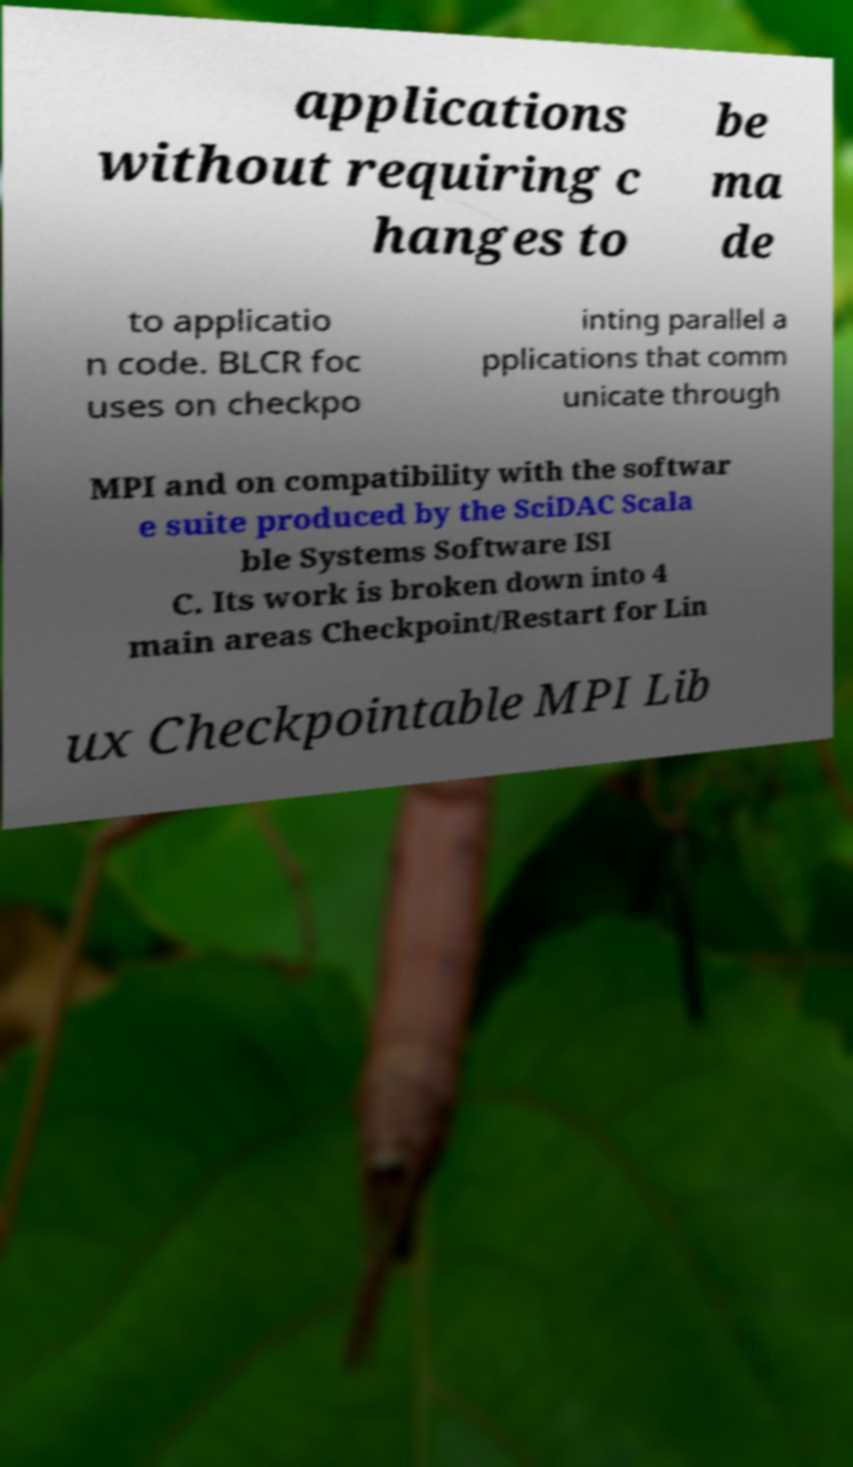Please identify and transcribe the text found in this image. applications without requiring c hanges to be ma de to applicatio n code. BLCR foc uses on checkpo inting parallel a pplications that comm unicate through MPI and on compatibility with the softwar e suite produced by the SciDAC Scala ble Systems Software ISI C. Its work is broken down into 4 main areas Checkpoint/Restart for Lin ux Checkpointable MPI Lib 